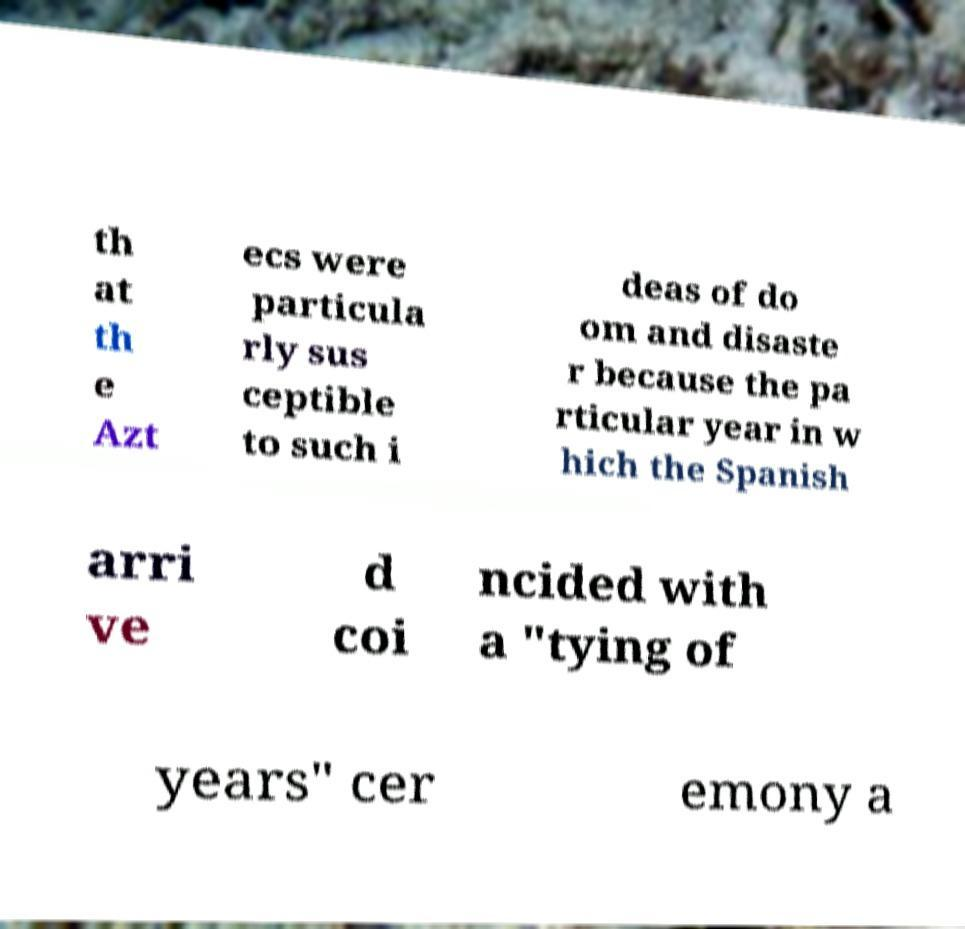There's text embedded in this image that I need extracted. Can you transcribe it verbatim? th at th e Azt ecs were particula rly sus ceptible to such i deas of do om and disaste r because the pa rticular year in w hich the Spanish arri ve d coi ncided with a "tying of years" cer emony a 